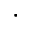<formula> <loc_0><loc_0><loc_500><loc_500>\cdot</formula> 